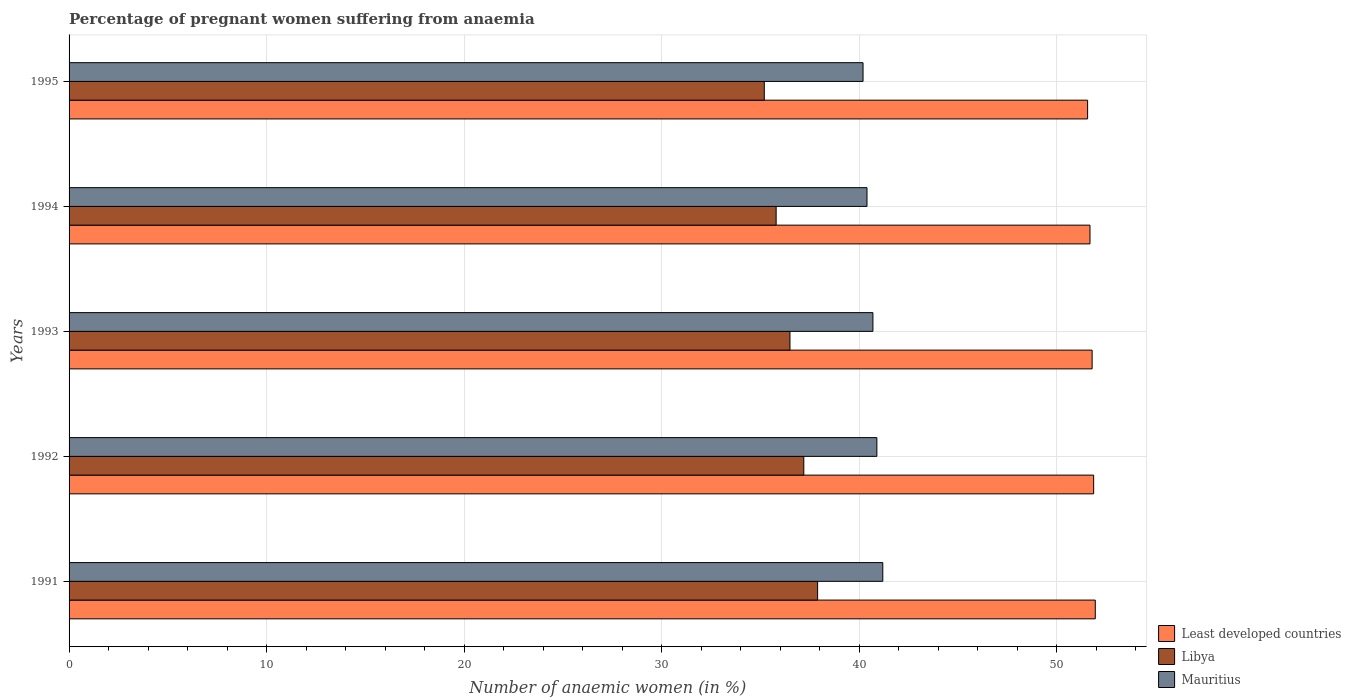How many different coloured bars are there?
Your answer should be very brief. 3. Are the number of bars on each tick of the Y-axis equal?
Your answer should be very brief. Yes. What is the label of the 3rd group of bars from the top?
Your answer should be very brief. 1993. What is the number of anaemic women in Libya in 1992?
Provide a succinct answer. 37.2. Across all years, what is the maximum number of anaemic women in Libya?
Offer a very short reply. 37.9. Across all years, what is the minimum number of anaemic women in Mauritius?
Provide a succinct answer. 40.2. In which year was the number of anaemic women in Mauritius minimum?
Make the answer very short. 1995. What is the total number of anaemic women in Least developed countries in the graph?
Keep it short and to the point. 258.89. What is the difference between the number of anaemic women in Least developed countries in 1992 and that in 1994?
Your answer should be very brief. 0.19. What is the difference between the number of anaemic women in Least developed countries in 1994 and the number of anaemic women in Libya in 1993?
Offer a terse response. 15.19. What is the average number of anaemic women in Least developed countries per year?
Give a very brief answer. 51.78. In the year 1992, what is the difference between the number of anaemic women in Libya and number of anaemic women in Least developed countries?
Offer a terse response. -14.68. What is the ratio of the number of anaemic women in Least developed countries in 1992 to that in 1994?
Offer a terse response. 1. What is the difference between the highest and the second highest number of anaemic women in Least developed countries?
Offer a terse response. 0.08. What is the difference between the highest and the lowest number of anaemic women in Mauritius?
Keep it short and to the point. 1. In how many years, is the number of anaemic women in Libya greater than the average number of anaemic women in Libya taken over all years?
Your answer should be compact. 2. What does the 2nd bar from the top in 1992 represents?
Your answer should be compact. Libya. What does the 3rd bar from the bottom in 1993 represents?
Your response must be concise. Mauritius. How many bars are there?
Offer a terse response. 15. Are all the bars in the graph horizontal?
Offer a terse response. Yes. Are the values on the major ticks of X-axis written in scientific E-notation?
Offer a terse response. No. Does the graph contain any zero values?
Keep it short and to the point. No. How many legend labels are there?
Your answer should be very brief. 3. What is the title of the graph?
Keep it short and to the point. Percentage of pregnant women suffering from anaemia. What is the label or title of the X-axis?
Offer a terse response. Number of anaemic women (in %). What is the Number of anaemic women (in %) in Least developed countries in 1991?
Your answer should be very brief. 51.96. What is the Number of anaemic women (in %) in Libya in 1991?
Your answer should be very brief. 37.9. What is the Number of anaemic women (in %) of Mauritius in 1991?
Ensure brevity in your answer.  41.2. What is the Number of anaemic women (in %) in Least developed countries in 1992?
Provide a short and direct response. 51.88. What is the Number of anaemic women (in %) of Libya in 1992?
Provide a short and direct response. 37.2. What is the Number of anaemic women (in %) of Mauritius in 1992?
Your answer should be compact. 40.9. What is the Number of anaemic women (in %) of Least developed countries in 1993?
Give a very brief answer. 51.8. What is the Number of anaemic women (in %) in Libya in 1993?
Your answer should be very brief. 36.5. What is the Number of anaemic women (in %) in Mauritius in 1993?
Ensure brevity in your answer.  40.7. What is the Number of anaemic women (in %) of Least developed countries in 1994?
Make the answer very short. 51.69. What is the Number of anaemic women (in %) in Libya in 1994?
Offer a terse response. 35.8. What is the Number of anaemic women (in %) in Mauritius in 1994?
Offer a terse response. 40.4. What is the Number of anaemic women (in %) in Least developed countries in 1995?
Your answer should be very brief. 51.57. What is the Number of anaemic women (in %) of Libya in 1995?
Your response must be concise. 35.2. What is the Number of anaemic women (in %) in Mauritius in 1995?
Make the answer very short. 40.2. Across all years, what is the maximum Number of anaemic women (in %) of Least developed countries?
Offer a terse response. 51.96. Across all years, what is the maximum Number of anaemic women (in %) in Libya?
Ensure brevity in your answer.  37.9. Across all years, what is the maximum Number of anaemic women (in %) of Mauritius?
Provide a succinct answer. 41.2. Across all years, what is the minimum Number of anaemic women (in %) of Least developed countries?
Your answer should be compact. 51.57. Across all years, what is the minimum Number of anaemic women (in %) in Libya?
Offer a very short reply. 35.2. Across all years, what is the minimum Number of anaemic women (in %) of Mauritius?
Offer a terse response. 40.2. What is the total Number of anaemic women (in %) of Least developed countries in the graph?
Give a very brief answer. 258.89. What is the total Number of anaemic women (in %) of Libya in the graph?
Your answer should be compact. 182.6. What is the total Number of anaemic women (in %) in Mauritius in the graph?
Your answer should be compact. 203.4. What is the difference between the Number of anaemic women (in %) of Least developed countries in 1991 and that in 1992?
Give a very brief answer. 0.08. What is the difference between the Number of anaemic women (in %) in Libya in 1991 and that in 1992?
Your answer should be compact. 0.7. What is the difference between the Number of anaemic women (in %) of Least developed countries in 1991 and that in 1993?
Offer a very short reply. 0.16. What is the difference between the Number of anaemic women (in %) in Least developed countries in 1991 and that in 1994?
Offer a very short reply. 0.27. What is the difference between the Number of anaemic women (in %) in Mauritius in 1991 and that in 1994?
Provide a short and direct response. 0.8. What is the difference between the Number of anaemic women (in %) of Least developed countries in 1991 and that in 1995?
Provide a short and direct response. 0.39. What is the difference between the Number of anaemic women (in %) in Libya in 1991 and that in 1995?
Offer a very short reply. 2.7. What is the difference between the Number of anaemic women (in %) in Least developed countries in 1992 and that in 1993?
Keep it short and to the point. 0.08. What is the difference between the Number of anaemic women (in %) of Libya in 1992 and that in 1993?
Provide a succinct answer. 0.7. What is the difference between the Number of anaemic women (in %) of Least developed countries in 1992 and that in 1994?
Make the answer very short. 0.19. What is the difference between the Number of anaemic women (in %) of Least developed countries in 1992 and that in 1995?
Offer a terse response. 0.31. What is the difference between the Number of anaemic women (in %) in Libya in 1992 and that in 1995?
Give a very brief answer. 2. What is the difference between the Number of anaemic women (in %) in Mauritius in 1992 and that in 1995?
Keep it short and to the point. 0.7. What is the difference between the Number of anaemic women (in %) in Least developed countries in 1993 and that in 1994?
Offer a very short reply. 0.11. What is the difference between the Number of anaemic women (in %) in Least developed countries in 1993 and that in 1995?
Offer a terse response. 0.23. What is the difference between the Number of anaemic women (in %) of Least developed countries in 1994 and that in 1995?
Give a very brief answer. 0.12. What is the difference between the Number of anaemic women (in %) in Libya in 1994 and that in 1995?
Provide a short and direct response. 0.6. What is the difference between the Number of anaemic women (in %) in Mauritius in 1994 and that in 1995?
Keep it short and to the point. 0.2. What is the difference between the Number of anaemic women (in %) of Least developed countries in 1991 and the Number of anaemic women (in %) of Libya in 1992?
Offer a terse response. 14.76. What is the difference between the Number of anaemic women (in %) in Least developed countries in 1991 and the Number of anaemic women (in %) in Mauritius in 1992?
Your answer should be very brief. 11.06. What is the difference between the Number of anaemic women (in %) of Least developed countries in 1991 and the Number of anaemic women (in %) of Libya in 1993?
Give a very brief answer. 15.46. What is the difference between the Number of anaemic women (in %) in Least developed countries in 1991 and the Number of anaemic women (in %) in Mauritius in 1993?
Keep it short and to the point. 11.26. What is the difference between the Number of anaemic women (in %) of Least developed countries in 1991 and the Number of anaemic women (in %) of Libya in 1994?
Give a very brief answer. 16.16. What is the difference between the Number of anaemic women (in %) of Least developed countries in 1991 and the Number of anaemic women (in %) of Mauritius in 1994?
Keep it short and to the point. 11.56. What is the difference between the Number of anaemic women (in %) in Least developed countries in 1991 and the Number of anaemic women (in %) in Libya in 1995?
Keep it short and to the point. 16.76. What is the difference between the Number of anaemic women (in %) of Least developed countries in 1991 and the Number of anaemic women (in %) of Mauritius in 1995?
Provide a short and direct response. 11.76. What is the difference between the Number of anaemic women (in %) of Least developed countries in 1992 and the Number of anaemic women (in %) of Libya in 1993?
Make the answer very short. 15.38. What is the difference between the Number of anaemic women (in %) of Least developed countries in 1992 and the Number of anaemic women (in %) of Mauritius in 1993?
Offer a very short reply. 11.18. What is the difference between the Number of anaemic women (in %) of Least developed countries in 1992 and the Number of anaemic women (in %) of Libya in 1994?
Offer a terse response. 16.08. What is the difference between the Number of anaemic women (in %) in Least developed countries in 1992 and the Number of anaemic women (in %) in Mauritius in 1994?
Your answer should be very brief. 11.48. What is the difference between the Number of anaemic women (in %) in Libya in 1992 and the Number of anaemic women (in %) in Mauritius in 1994?
Give a very brief answer. -3.2. What is the difference between the Number of anaemic women (in %) in Least developed countries in 1992 and the Number of anaemic women (in %) in Libya in 1995?
Provide a succinct answer. 16.68. What is the difference between the Number of anaemic women (in %) of Least developed countries in 1992 and the Number of anaemic women (in %) of Mauritius in 1995?
Provide a succinct answer. 11.68. What is the difference between the Number of anaemic women (in %) in Least developed countries in 1993 and the Number of anaemic women (in %) in Libya in 1994?
Give a very brief answer. 16. What is the difference between the Number of anaemic women (in %) in Least developed countries in 1993 and the Number of anaemic women (in %) in Mauritius in 1994?
Your answer should be compact. 11.4. What is the difference between the Number of anaemic women (in %) in Least developed countries in 1993 and the Number of anaemic women (in %) in Libya in 1995?
Offer a terse response. 16.6. What is the difference between the Number of anaemic women (in %) of Least developed countries in 1993 and the Number of anaemic women (in %) of Mauritius in 1995?
Keep it short and to the point. 11.6. What is the difference between the Number of anaemic women (in %) of Libya in 1993 and the Number of anaemic women (in %) of Mauritius in 1995?
Make the answer very short. -3.7. What is the difference between the Number of anaemic women (in %) in Least developed countries in 1994 and the Number of anaemic women (in %) in Libya in 1995?
Ensure brevity in your answer.  16.49. What is the difference between the Number of anaemic women (in %) in Least developed countries in 1994 and the Number of anaemic women (in %) in Mauritius in 1995?
Your response must be concise. 11.49. What is the difference between the Number of anaemic women (in %) of Libya in 1994 and the Number of anaemic women (in %) of Mauritius in 1995?
Make the answer very short. -4.4. What is the average Number of anaemic women (in %) of Least developed countries per year?
Offer a terse response. 51.78. What is the average Number of anaemic women (in %) in Libya per year?
Give a very brief answer. 36.52. What is the average Number of anaemic women (in %) of Mauritius per year?
Your answer should be very brief. 40.68. In the year 1991, what is the difference between the Number of anaemic women (in %) in Least developed countries and Number of anaemic women (in %) in Libya?
Provide a short and direct response. 14.06. In the year 1991, what is the difference between the Number of anaemic women (in %) in Least developed countries and Number of anaemic women (in %) in Mauritius?
Your answer should be compact. 10.76. In the year 1992, what is the difference between the Number of anaemic women (in %) of Least developed countries and Number of anaemic women (in %) of Libya?
Your answer should be very brief. 14.68. In the year 1992, what is the difference between the Number of anaemic women (in %) in Least developed countries and Number of anaemic women (in %) in Mauritius?
Ensure brevity in your answer.  10.98. In the year 1993, what is the difference between the Number of anaemic women (in %) of Least developed countries and Number of anaemic women (in %) of Libya?
Your answer should be very brief. 15.3. In the year 1993, what is the difference between the Number of anaemic women (in %) in Least developed countries and Number of anaemic women (in %) in Mauritius?
Provide a succinct answer. 11.1. In the year 1993, what is the difference between the Number of anaemic women (in %) in Libya and Number of anaemic women (in %) in Mauritius?
Make the answer very short. -4.2. In the year 1994, what is the difference between the Number of anaemic women (in %) of Least developed countries and Number of anaemic women (in %) of Libya?
Your answer should be very brief. 15.89. In the year 1994, what is the difference between the Number of anaemic women (in %) in Least developed countries and Number of anaemic women (in %) in Mauritius?
Ensure brevity in your answer.  11.29. In the year 1995, what is the difference between the Number of anaemic women (in %) of Least developed countries and Number of anaemic women (in %) of Libya?
Offer a very short reply. 16.37. In the year 1995, what is the difference between the Number of anaemic women (in %) in Least developed countries and Number of anaemic women (in %) in Mauritius?
Ensure brevity in your answer.  11.37. What is the ratio of the Number of anaemic women (in %) of Least developed countries in 1991 to that in 1992?
Your answer should be compact. 1. What is the ratio of the Number of anaemic women (in %) in Libya in 1991 to that in 1992?
Offer a very short reply. 1.02. What is the ratio of the Number of anaemic women (in %) of Mauritius in 1991 to that in 1992?
Offer a terse response. 1.01. What is the ratio of the Number of anaemic women (in %) of Least developed countries in 1991 to that in 1993?
Offer a very short reply. 1. What is the ratio of the Number of anaemic women (in %) in Libya in 1991 to that in 1993?
Keep it short and to the point. 1.04. What is the ratio of the Number of anaemic women (in %) in Mauritius in 1991 to that in 1993?
Your answer should be very brief. 1.01. What is the ratio of the Number of anaemic women (in %) of Least developed countries in 1991 to that in 1994?
Your response must be concise. 1.01. What is the ratio of the Number of anaemic women (in %) in Libya in 1991 to that in 1994?
Your answer should be compact. 1.06. What is the ratio of the Number of anaemic women (in %) in Mauritius in 1991 to that in 1994?
Your answer should be compact. 1.02. What is the ratio of the Number of anaemic women (in %) in Least developed countries in 1991 to that in 1995?
Make the answer very short. 1.01. What is the ratio of the Number of anaemic women (in %) of Libya in 1991 to that in 1995?
Ensure brevity in your answer.  1.08. What is the ratio of the Number of anaemic women (in %) of Mauritius in 1991 to that in 1995?
Your answer should be very brief. 1.02. What is the ratio of the Number of anaemic women (in %) of Libya in 1992 to that in 1993?
Your answer should be very brief. 1.02. What is the ratio of the Number of anaemic women (in %) in Libya in 1992 to that in 1994?
Give a very brief answer. 1.04. What is the ratio of the Number of anaemic women (in %) of Mauritius in 1992 to that in 1994?
Your response must be concise. 1.01. What is the ratio of the Number of anaemic women (in %) in Least developed countries in 1992 to that in 1995?
Your response must be concise. 1.01. What is the ratio of the Number of anaemic women (in %) in Libya in 1992 to that in 1995?
Give a very brief answer. 1.06. What is the ratio of the Number of anaemic women (in %) of Mauritius in 1992 to that in 1995?
Provide a succinct answer. 1.02. What is the ratio of the Number of anaemic women (in %) in Least developed countries in 1993 to that in 1994?
Offer a terse response. 1. What is the ratio of the Number of anaemic women (in %) in Libya in 1993 to that in 1994?
Give a very brief answer. 1.02. What is the ratio of the Number of anaemic women (in %) in Mauritius in 1993 to that in 1994?
Offer a terse response. 1.01. What is the ratio of the Number of anaemic women (in %) of Libya in 1993 to that in 1995?
Provide a succinct answer. 1.04. What is the ratio of the Number of anaemic women (in %) of Mauritius in 1993 to that in 1995?
Your answer should be compact. 1.01. What is the ratio of the Number of anaemic women (in %) of Mauritius in 1994 to that in 1995?
Provide a short and direct response. 1. What is the difference between the highest and the second highest Number of anaemic women (in %) of Least developed countries?
Your answer should be compact. 0.08. What is the difference between the highest and the lowest Number of anaemic women (in %) in Least developed countries?
Offer a terse response. 0.39. What is the difference between the highest and the lowest Number of anaemic women (in %) in Libya?
Offer a terse response. 2.7. What is the difference between the highest and the lowest Number of anaemic women (in %) of Mauritius?
Offer a terse response. 1. 